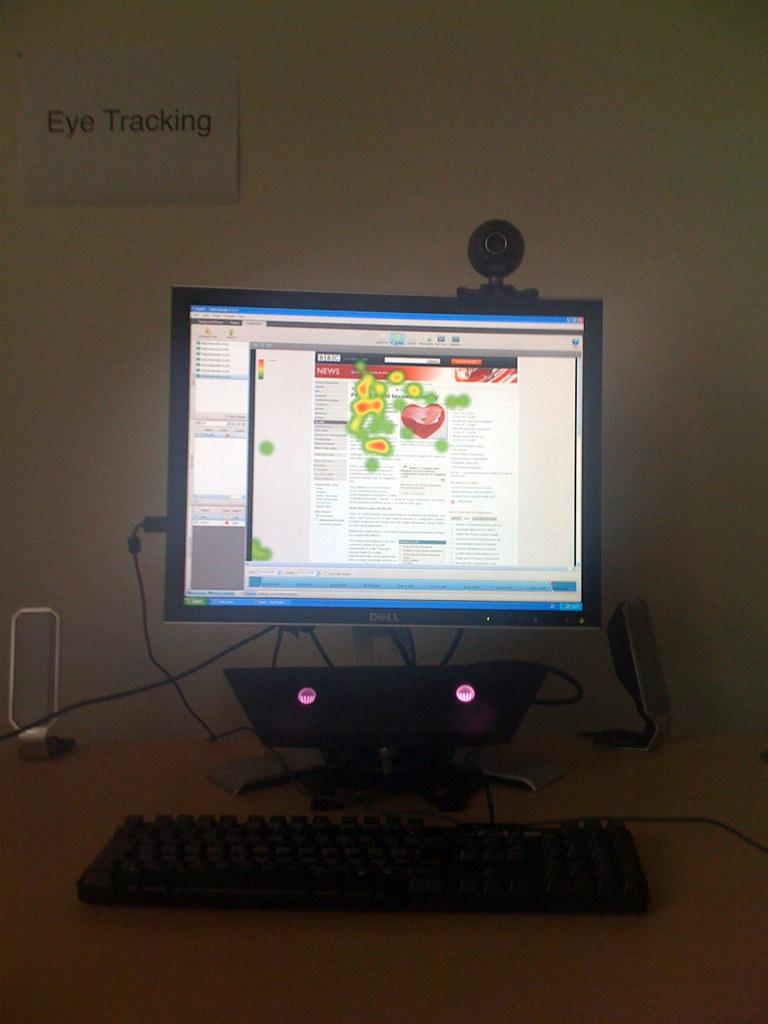<image>
Provide a brief description of the given image. A dell computer is sitting in a dark room under a sign that says "Eye Tracking". 